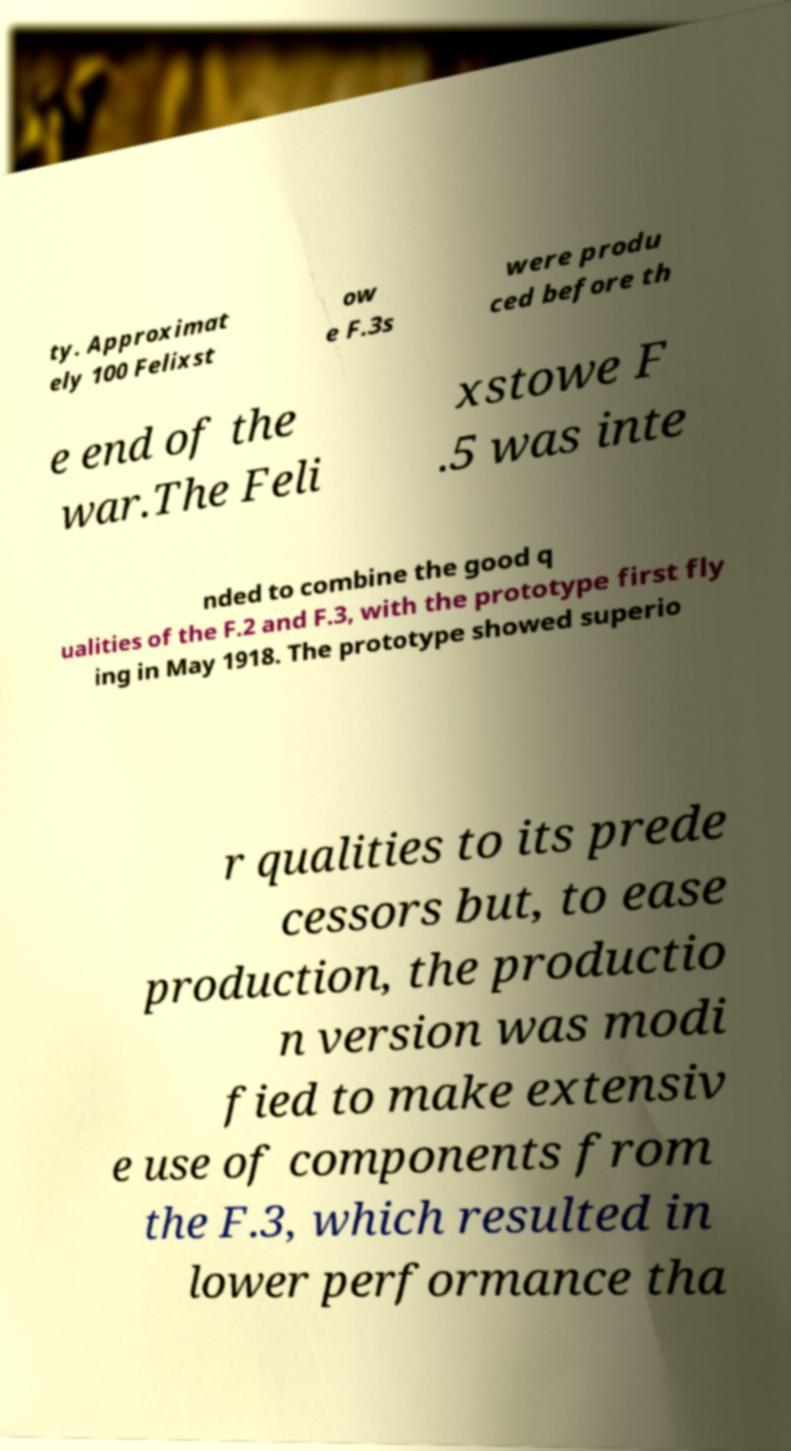Could you extract and type out the text from this image? ty. Approximat ely 100 Felixst ow e F.3s were produ ced before th e end of the war.The Feli xstowe F .5 was inte nded to combine the good q ualities of the F.2 and F.3, with the prototype first fly ing in May 1918. The prototype showed superio r qualities to its prede cessors but, to ease production, the productio n version was modi fied to make extensiv e use of components from the F.3, which resulted in lower performance tha 